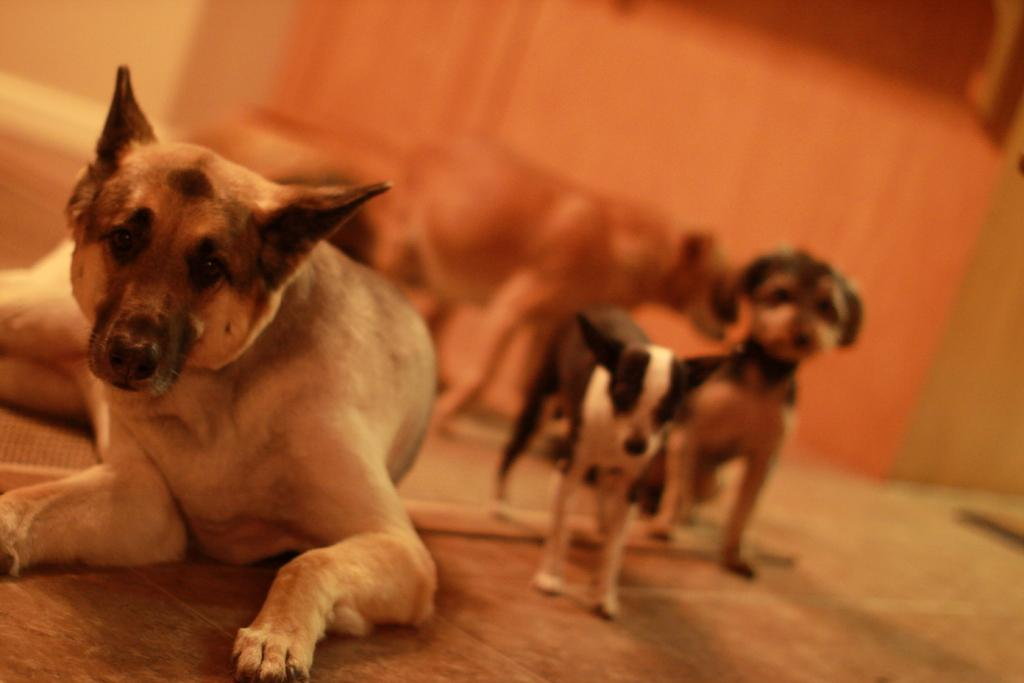What type of animals are in the image? There are dogs in the image. Can you describe the background of the image? The background of the image is blurry. How many trees can be seen helping the dogs in the image? There are no trees present in the image, and trees cannot help dogs. 